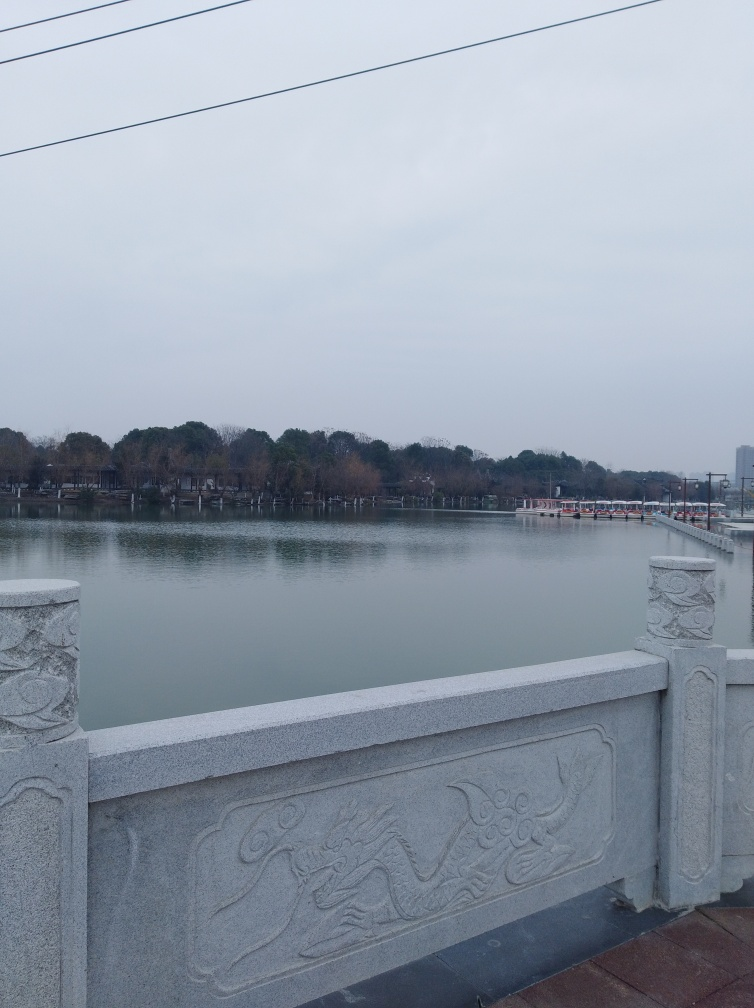What is the color tone of the image?
A. neutral
B. cooler
C. warmer
D. vibrant
Answer with the option's letter from the given choices directly.
 B. 